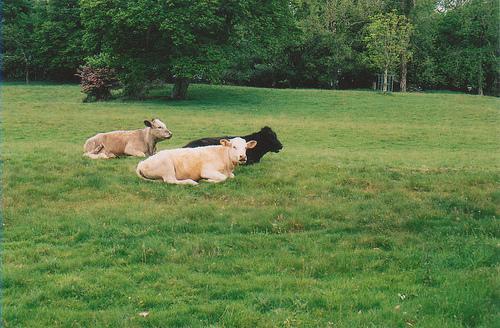How many cows are there?
Give a very brief answer. 3. 